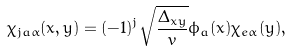Convert formula to latex. <formula><loc_0><loc_0><loc_500><loc_500>\chi _ { j a \alpha } ( x , y ) = ( - 1 ) ^ { j } \sqrt { \frac { \Delta _ { x y } } { v } } \phi _ { a } ( x ) \chi _ { e \alpha } ( y ) ,</formula> 